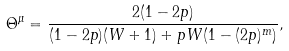<formula> <loc_0><loc_0><loc_500><loc_500>\Theta ^ { \mu } = \frac { 2 ( 1 - 2 p ) } { ( 1 - 2 p ) ( W + 1 ) + p W ( 1 - ( 2 p ) ^ { m } ) } ,</formula> 